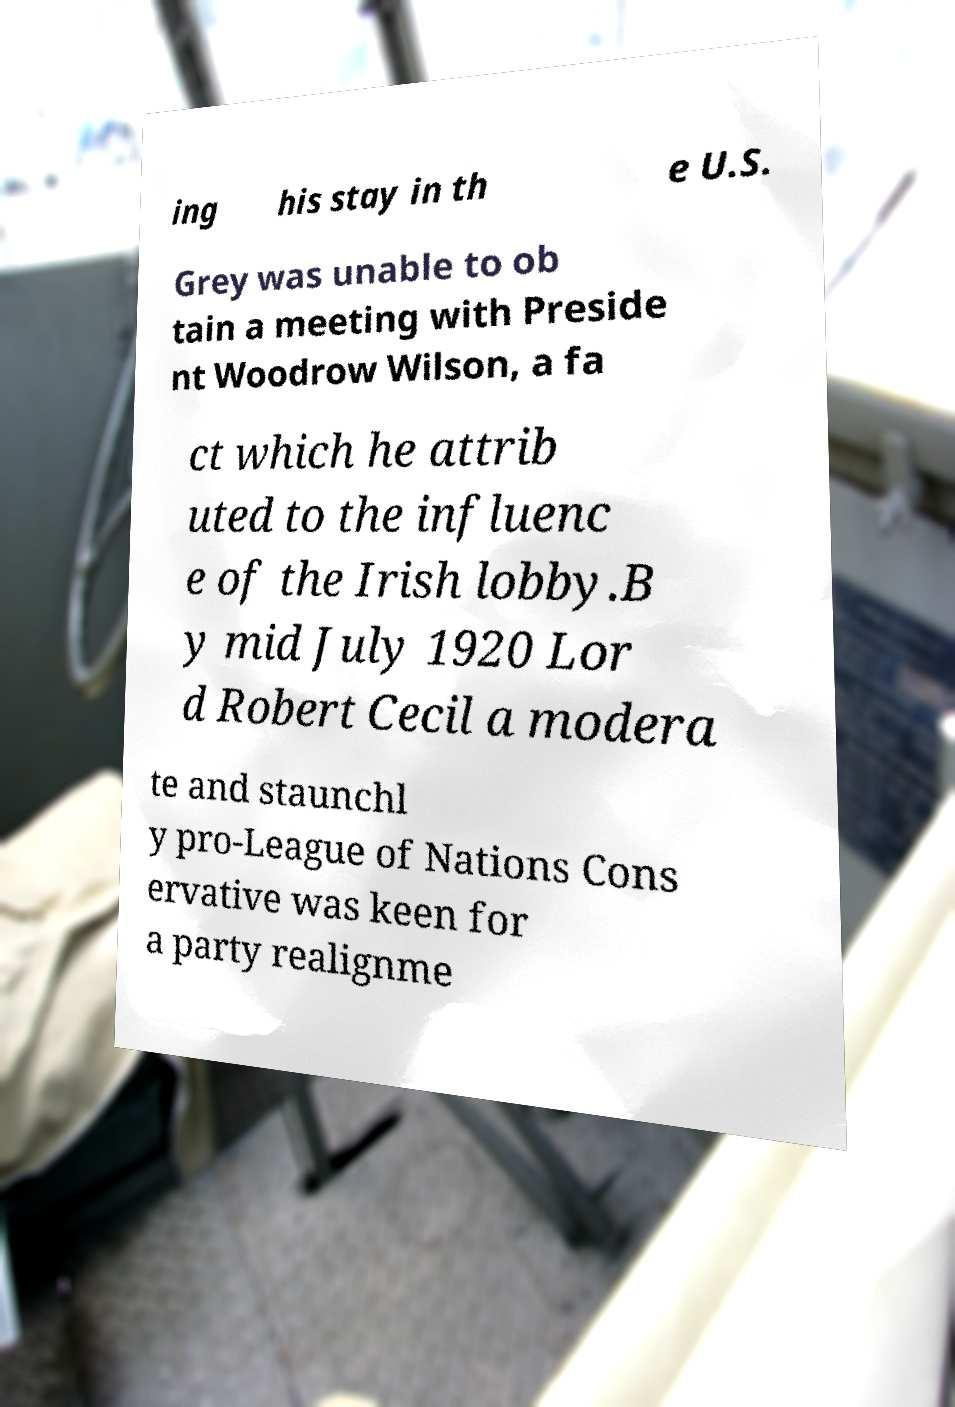I need the written content from this picture converted into text. Can you do that? ing his stay in th e U.S. Grey was unable to ob tain a meeting with Preside nt Woodrow Wilson, a fa ct which he attrib uted to the influenc e of the Irish lobby.B y mid July 1920 Lor d Robert Cecil a modera te and staunchl y pro-League of Nations Cons ervative was keen for a party realignme 